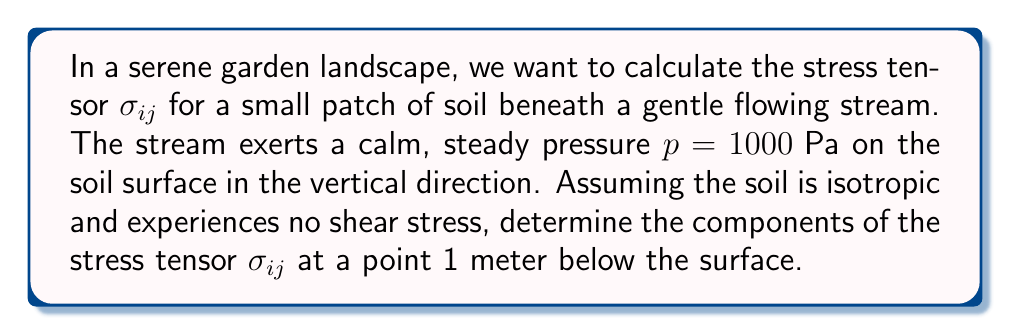Teach me how to tackle this problem. Let's approach this step-by-step:

1) In a peaceful garden setting, we can assume the stress is primarily due to the gentle pressure of the stream and the weight of the soil above our point of interest.

2) For an isotropic material with no shear stress, the stress tensor will be diagonal:

   $$\sigma_{ij} = \begin{pmatrix}
   \sigma_{xx} & 0 & 0 \\
   0 & \sigma_{yy} & 0 \\
   0 & 0 & \sigma_{zz}
   \end{pmatrix}$$

3) Let's define the z-axis as pointing downward. The vertical stress $\sigma_{zz}$ at 1 meter depth will be:
   
   $$\sigma_{zz} = p + \rho g h$$

   Where $p$ is the surface pressure, $\rho$ is the density of soil, $g$ is the acceleration due to gravity, and $h$ is the depth.

4) We're given $p = 1000 \text{ Pa}$. Let's assume a typical soil density of $\rho = 1600 \text{ kg/m}^3$, $g = 9.81 \text{ m/s}^2$, and $h = 1 \text{ m}$.

5) Calculating $\sigma_{zz}$:
   
   $$\sigma_{zz} = 1000 + (1600)(9.81)(1) = 16696 \text{ Pa}$$

6) For the horizontal stresses, we can use the at-rest earth pressure coefficient $K_0$, typically around 0.5 for most soils:

   $$\sigma_{xx} = \sigma_{yy} = K_0 \sigma_{zz} = 0.5 (16696) = 8348 \text{ Pa}$$

7) Therefore, our stress tensor is:

   $$\sigma_{ij} = \begin{pmatrix}
   8348 & 0 & 0 \\
   0 & 8348 & 0 \\
   0 & 0 & 16696
   \end{pmatrix} \text{ Pa}$$
Answer: $$\sigma_{ij} = \begin{pmatrix}
8348 & 0 & 0 \\
0 & 8348 & 0 \\
0 & 0 & 16696
\end{pmatrix} \text{ Pa}$$ 